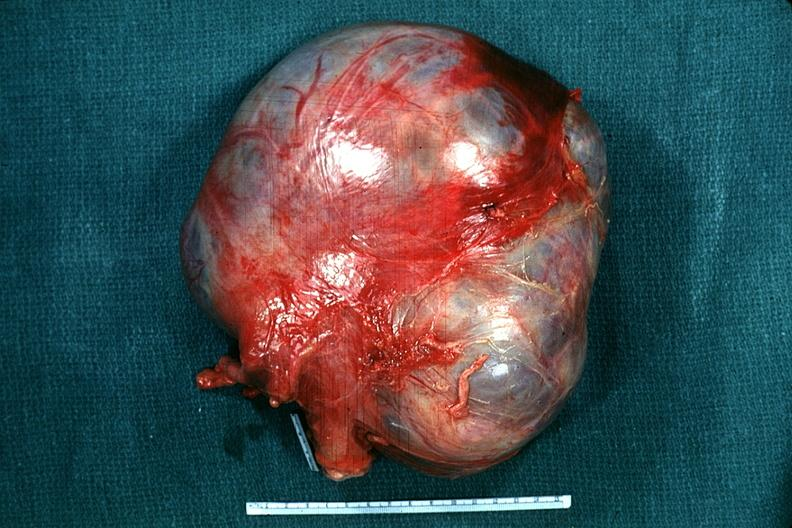what is present?
Answer the question using a single word or phrase. Mucinous cystadenocarcinoma 